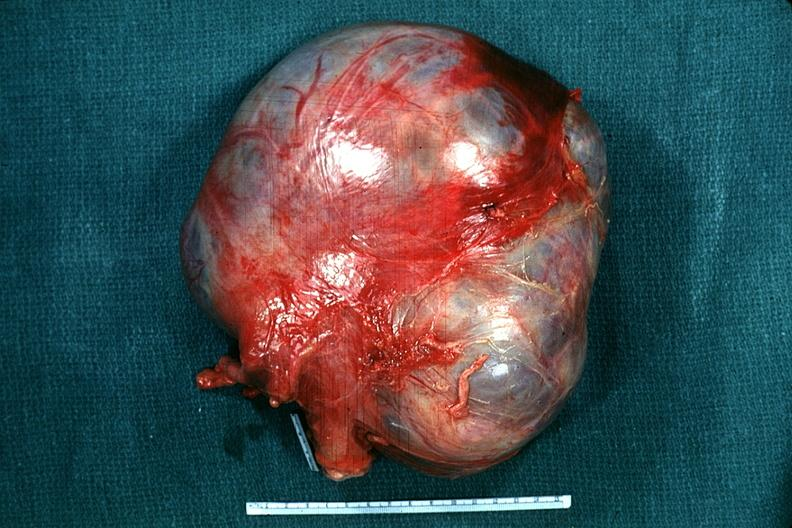what is present?
Answer the question using a single word or phrase. Mucinous cystadenocarcinoma 